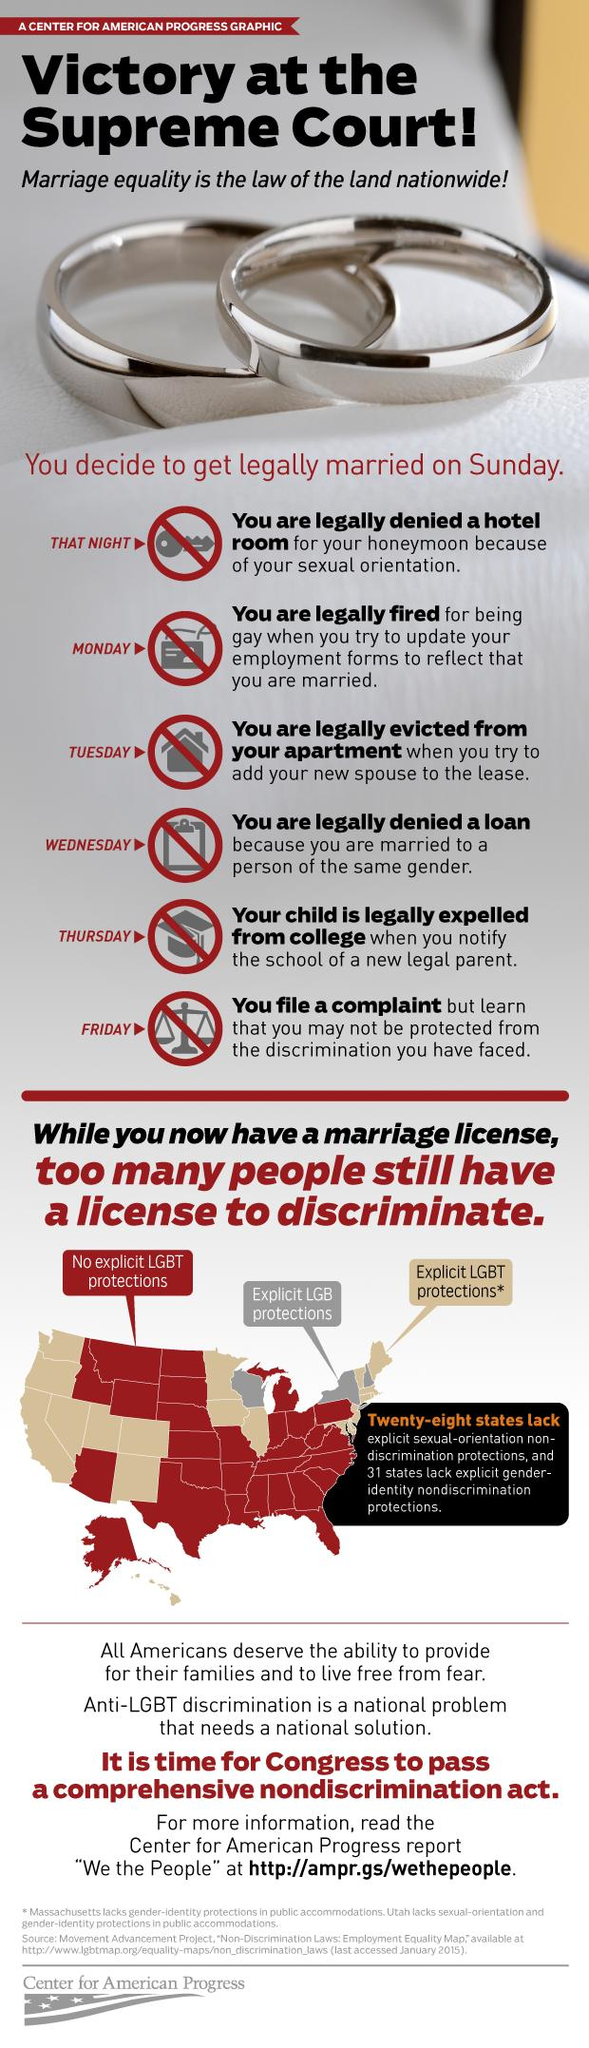Highlight a few significant elements in this photo. The ruling party in the United States is Congress. In the United States, Saturday is the day that is exempt from the list of complications that commonly arise on marriage days, except for Sunday, Thursday, and Friday. There are 6 marriage and law complications listed in the infographic in the USA. In the United States, there are currently three states that lack explicit protections for LGB individuals. 